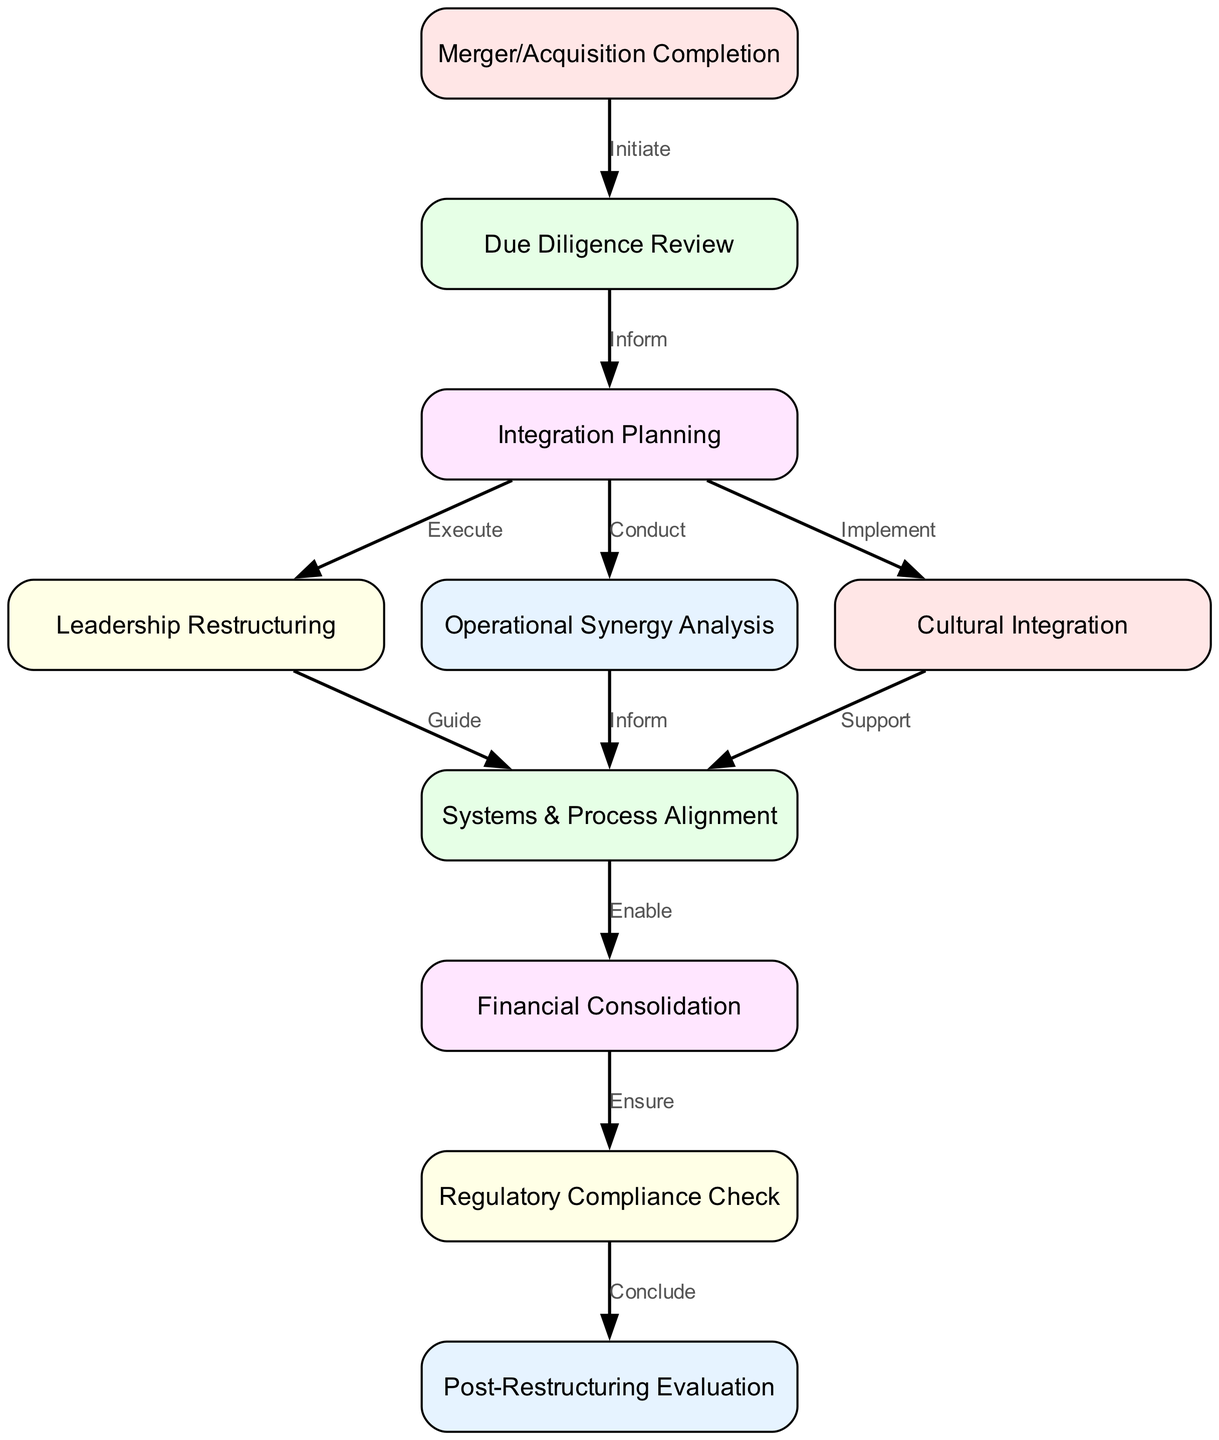What is the first step after the merger or acquisition completion? The first node in the diagram that follows the "Merger/Acquisition Completion" is "Due Diligence Review".
Answer: Due Diligence Review How many nodes are present in the diagram? There are 10 nodes listed in the diagram, representing distinct steps in the corporate restructuring process.
Answer: 10 What action follows the "Integration Planning" node? According to the edges linked to "Integration Planning", "Leadership Restructuring", "Operational Synergy Analysis", and "Cultural Integration" all follow this node as actions taken.
Answer: Leadership Restructuring, Operational Synergy Analysis, Cultural Integration What is the relationship between "Systems & Process Alignment" and "Financial Consolidation"? The edge from "Systems & Process Alignment" to "Financial Consolidation" indicates that "Systems & Process Alignment" enables "Financial Consolidation".
Answer: Enable Which step ensures compliance with regulations post-merger? After "Financial Consolidation", the next step is "Regulatory Compliance Check", ensuring all regulations are followed.
Answer: Regulatory Compliance Check What is the last step in the corporate restructuring process? The final node in the flow chart is "Post-Restructuring Evaluation", which indicates the conclusion of the entire process.
Answer: Post-Restructuring Evaluation Which nodes directly relate to leadership restructuring? The node "Leadership Restructuring" relates directly to "Integration Planning", which guides the restructuring process as shown by the edge connecting these two.
Answer: Integration Planning What action is taken after the "Cultural Integration"? The diagram shows that "Cultural Integration" supports the subsequent action, which is "Systems & Process Alignment".
Answer: Systems & Process Alignment What does the edge from "Due Diligence Review" to "Integration Planning" signify? The edge describes that the completion of "Due Diligence Review" informs the "Integration Planning" process as the next step.
Answer: Inform 